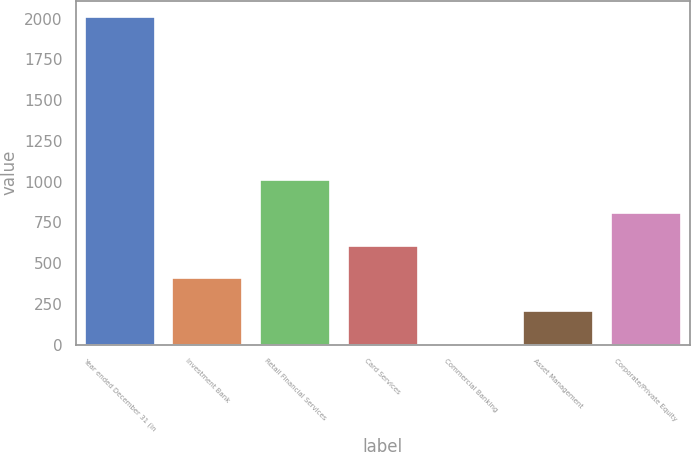Convert chart to OTSL. <chart><loc_0><loc_0><loc_500><loc_500><bar_chart><fcel>Year ended December 31 (in<fcel>Investment Bank<fcel>Retail Financial Services<fcel>Card Services<fcel>Commercial Banking<fcel>Asset Management<fcel>Corporate/Private Equity<nl><fcel>2009<fcel>406.6<fcel>1007.5<fcel>606.9<fcel>6<fcel>206.3<fcel>807.2<nl></chart> 